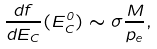Convert formula to latex. <formula><loc_0><loc_0><loc_500><loc_500>\frac { d f } { d E _ { C } } ( E _ { C } ^ { 0 } ) \sim \sigma \frac { M } { p _ { e } } ,</formula> 